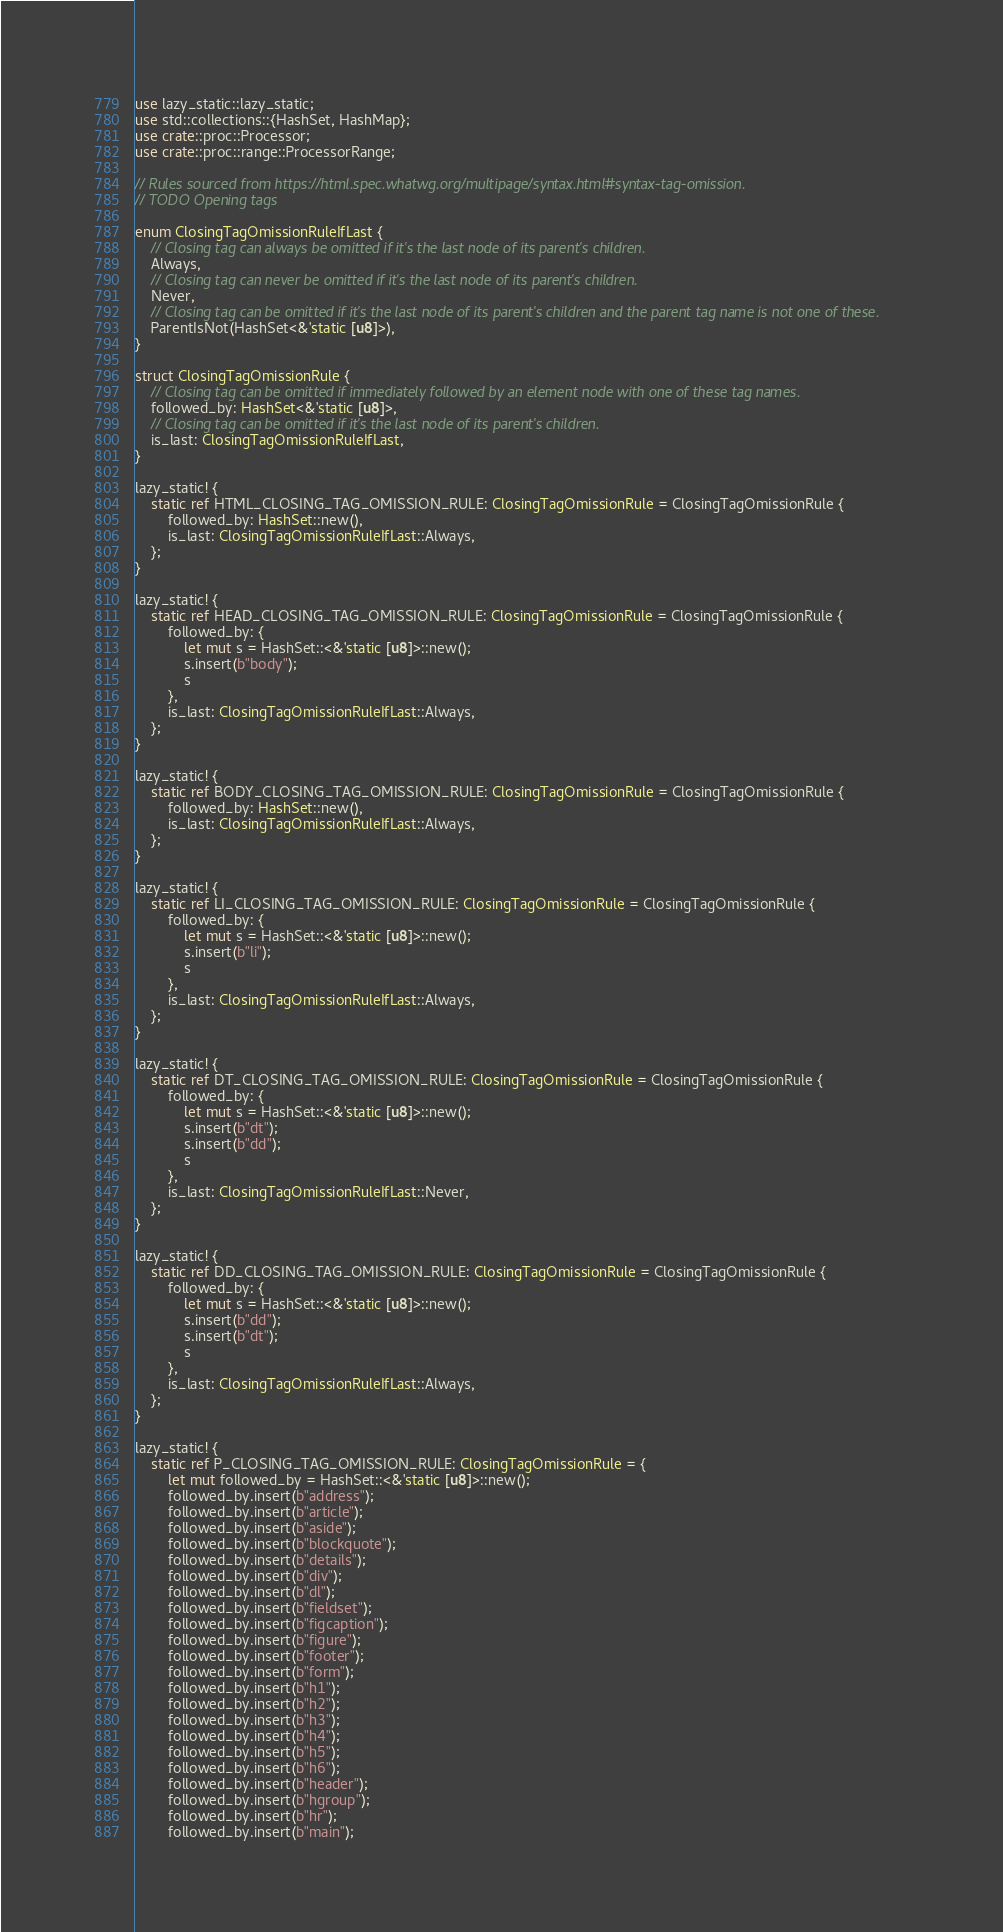Convert code to text. <code><loc_0><loc_0><loc_500><loc_500><_Rust_>use lazy_static::lazy_static;
use std::collections::{HashSet, HashMap};
use crate::proc::Processor;
use crate::proc::range::ProcessorRange;

// Rules sourced from https://html.spec.whatwg.org/multipage/syntax.html#syntax-tag-omission.
// TODO Opening tags

enum ClosingTagOmissionRuleIfLast {
    // Closing tag can always be omitted if it's the last node of its parent's children.
    Always,
    // Closing tag can never be omitted if it's the last node of its parent's children.
    Never,
    // Closing tag can be omitted if it's the last node of its parent's children and the parent tag name is not one of these.
    ParentIsNot(HashSet<&'static [u8]>),
}

struct ClosingTagOmissionRule {
    // Closing tag can be omitted if immediately followed by an element node with one of these tag names.
    followed_by: HashSet<&'static [u8]>,
    // Closing tag can be omitted if it's the last node of its parent's children.
    is_last: ClosingTagOmissionRuleIfLast,
}

lazy_static! {
    static ref HTML_CLOSING_TAG_OMISSION_RULE: ClosingTagOmissionRule = ClosingTagOmissionRule {
        followed_by: HashSet::new(),
        is_last: ClosingTagOmissionRuleIfLast::Always,
    };
}

lazy_static! {
    static ref HEAD_CLOSING_TAG_OMISSION_RULE: ClosingTagOmissionRule = ClosingTagOmissionRule {
        followed_by: {
            let mut s = HashSet::<&'static [u8]>::new();
            s.insert(b"body");
            s
        },
        is_last: ClosingTagOmissionRuleIfLast::Always,
    };
}

lazy_static! {
    static ref BODY_CLOSING_TAG_OMISSION_RULE: ClosingTagOmissionRule = ClosingTagOmissionRule {
        followed_by: HashSet::new(),
        is_last: ClosingTagOmissionRuleIfLast::Always,
    };
}

lazy_static! {
    static ref LI_CLOSING_TAG_OMISSION_RULE: ClosingTagOmissionRule = ClosingTagOmissionRule {
        followed_by: {
            let mut s = HashSet::<&'static [u8]>::new();
            s.insert(b"li");
            s
        },
        is_last: ClosingTagOmissionRuleIfLast::Always,
    };
}

lazy_static! {
    static ref DT_CLOSING_TAG_OMISSION_RULE: ClosingTagOmissionRule = ClosingTagOmissionRule {
        followed_by: {
            let mut s = HashSet::<&'static [u8]>::new();
            s.insert(b"dt");
            s.insert(b"dd");
            s
        },
        is_last: ClosingTagOmissionRuleIfLast::Never,
    };
}

lazy_static! {
    static ref DD_CLOSING_TAG_OMISSION_RULE: ClosingTagOmissionRule = ClosingTagOmissionRule {
        followed_by: {
            let mut s = HashSet::<&'static [u8]>::new();
            s.insert(b"dd");
            s.insert(b"dt");
            s
        },
        is_last: ClosingTagOmissionRuleIfLast::Always,
    };
}

lazy_static! {
    static ref P_CLOSING_TAG_OMISSION_RULE: ClosingTagOmissionRule = {
        let mut followed_by = HashSet::<&'static [u8]>::new();
        followed_by.insert(b"address");
        followed_by.insert(b"article");
        followed_by.insert(b"aside");
        followed_by.insert(b"blockquote");
        followed_by.insert(b"details");
        followed_by.insert(b"div");
        followed_by.insert(b"dl");
        followed_by.insert(b"fieldset");
        followed_by.insert(b"figcaption");
        followed_by.insert(b"figure");
        followed_by.insert(b"footer");
        followed_by.insert(b"form");
        followed_by.insert(b"h1");
        followed_by.insert(b"h2");
        followed_by.insert(b"h3");
        followed_by.insert(b"h4");
        followed_by.insert(b"h5");
        followed_by.insert(b"h6");
        followed_by.insert(b"header");
        followed_by.insert(b"hgroup");
        followed_by.insert(b"hr");
        followed_by.insert(b"main");</code> 